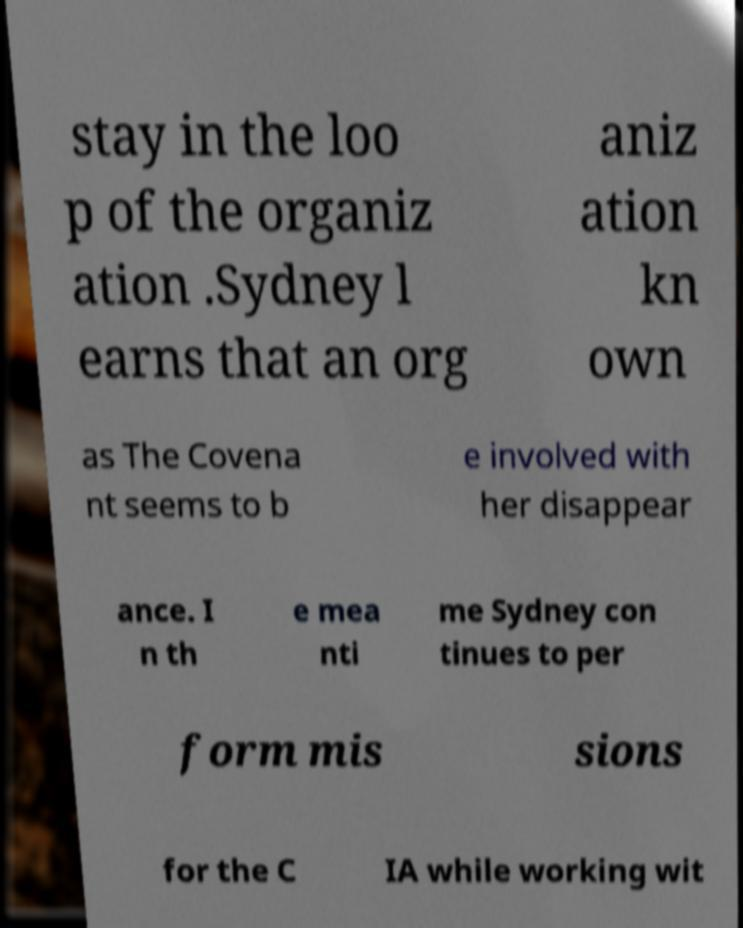Can you read and provide the text displayed in the image?This photo seems to have some interesting text. Can you extract and type it out for me? stay in the loo p of the organiz ation .Sydney l earns that an org aniz ation kn own as The Covena nt seems to b e involved with her disappear ance. I n th e mea nti me Sydney con tinues to per form mis sions for the C IA while working wit 